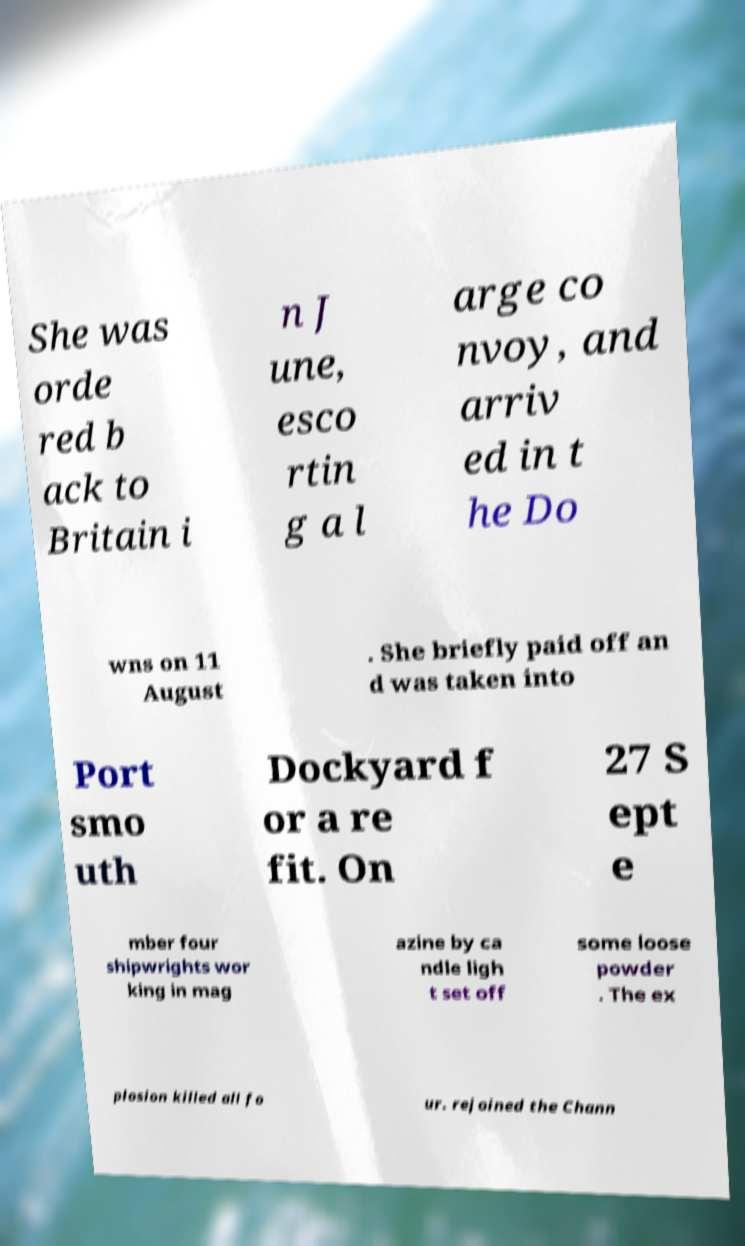There's text embedded in this image that I need extracted. Can you transcribe it verbatim? She was orde red b ack to Britain i n J une, esco rtin g a l arge co nvoy, and arriv ed in t he Do wns on 11 August . She briefly paid off an d was taken into Port smo uth Dockyard f or a re fit. On 27 S ept e mber four shipwrights wor king in mag azine by ca ndle ligh t set off some loose powder . The ex plosion killed all fo ur. rejoined the Chann 